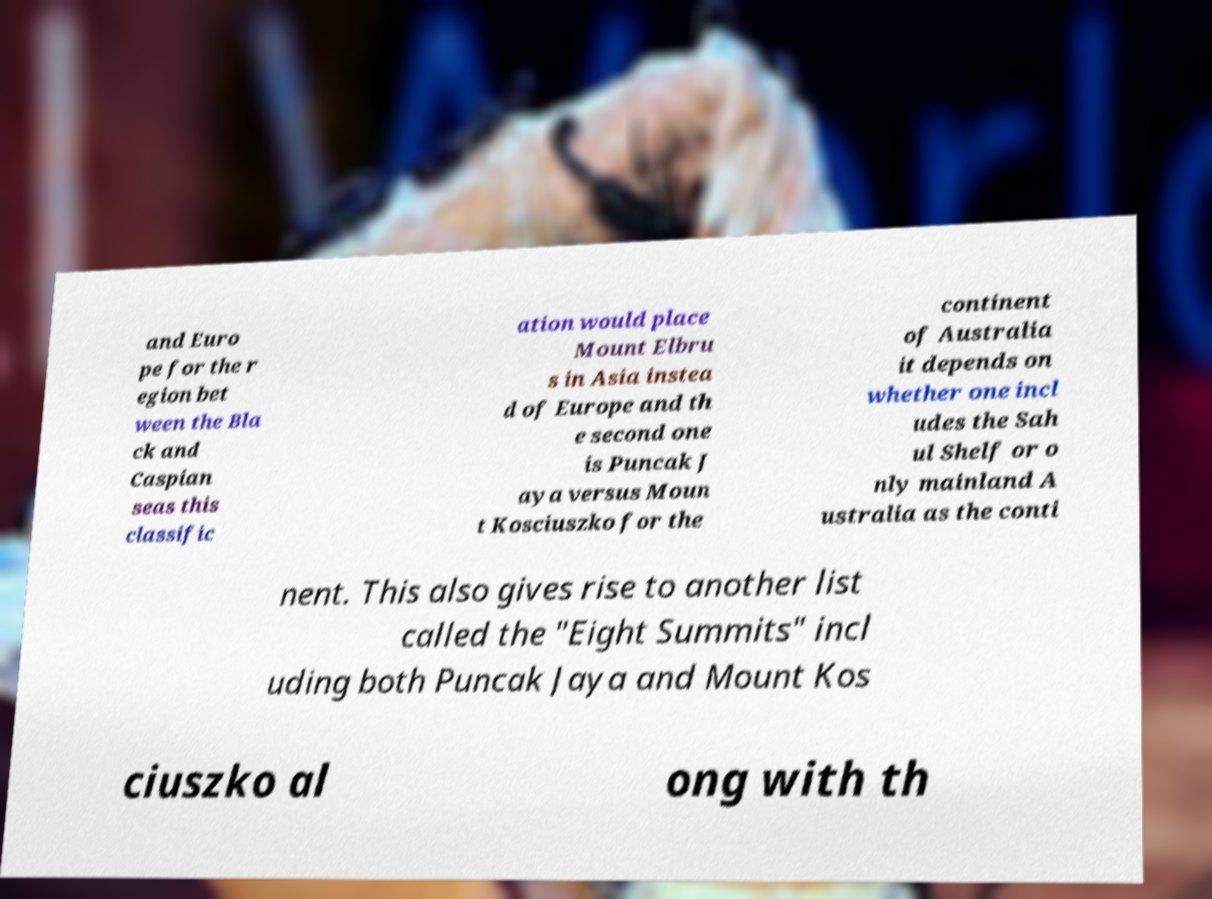Please identify and transcribe the text found in this image. and Euro pe for the r egion bet ween the Bla ck and Caspian seas this classific ation would place Mount Elbru s in Asia instea d of Europe and th e second one is Puncak J aya versus Moun t Kosciuszko for the continent of Australia it depends on whether one incl udes the Sah ul Shelf or o nly mainland A ustralia as the conti nent. This also gives rise to another list called the "Eight Summits" incl uding both Puncak Jaya and Mount Kos ciuszko al ong with th 